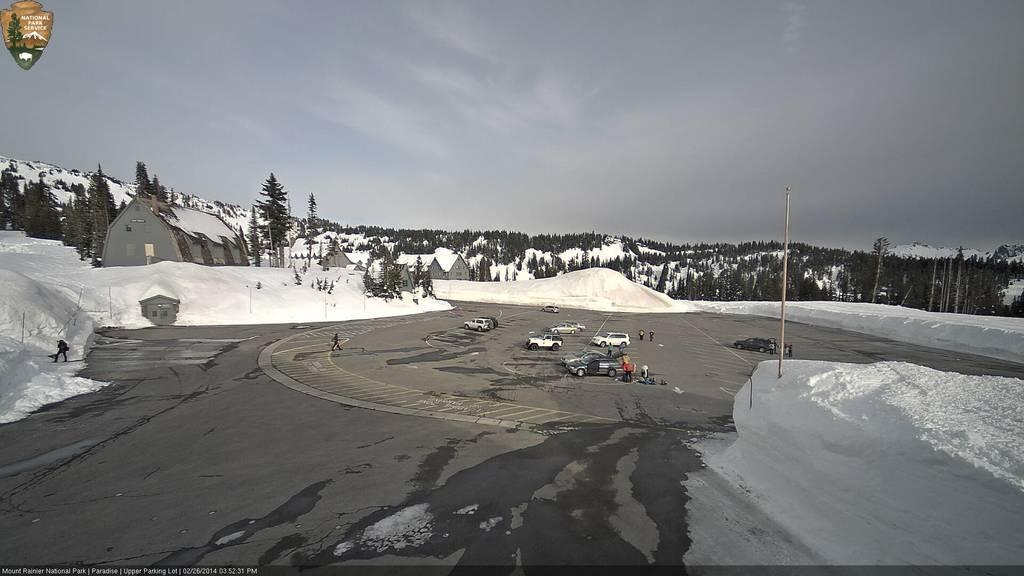How would you summarize this image in a sentence or two? In this image, there are vehicles and few people on the road. I can see the houses and trees on the snowy mountains. I can see a pole in the snow. In the top left corner of the image and in the bottom left corner of the image, I can see the watermarks. In the background, there is the sky. 